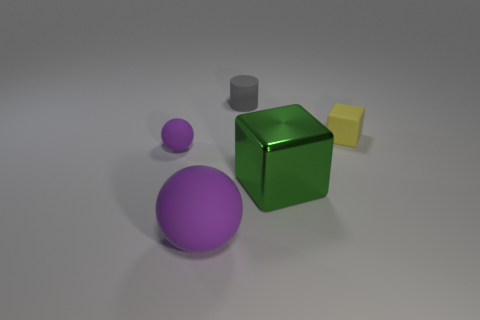There is a small cylinder; does it have the same color as the big object that is on the right side of the gray thing?
Ensure brevity in your answer.  No. Is the number of green cubes that are in front of the green shiny cube less than the number of green things?
Provide a short and direct response. Yes. What number of other objects are the same size as the rubber block?
Your response must be concise. 2. Is the shape of the thing behind the small block the same as  the shiny thing?
Your answer should be compact. No. Is the number of big purple rubber things behind the metal object greater than the number of small cylinders?
Your response must be concise. No. There is a tiny thing that is on the right side of the tiny purple object and on the left side of the big green metal cube; what material is it?
Offer a very short reply. Rubber. Is there any other thing that is the same shape as the big metallic thing?
Provide a succinct answer. Yes. What number of objects are on the right side of the tiny gray rubber thing and in front of the tiny block?
Provide a short and direct response. 1. What is the material of the green object?
Keep it short and to the point. Metal. Are there an equal number of big things behind the green shiny cube and tiny cylinders?
Ensure brevity in your answer.  No. 